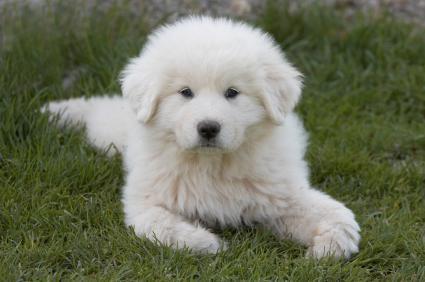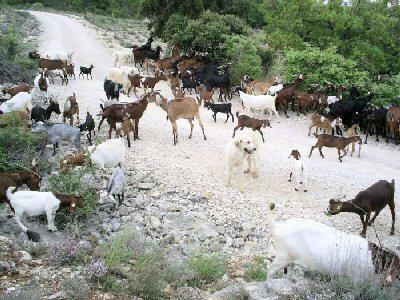The first image is the image on the left, the second image is the image on the right. Considering the images on both sides, is "An image shows a white dog with a herd of livestock." valid? Answer yes or no. Yes. The first image is the image on the left, the second image is the image on the right. Analyze the images presented: Is the assertion "The white dog is lying in the grass in the image on the left." valid? Answer yes or no. Yes. 